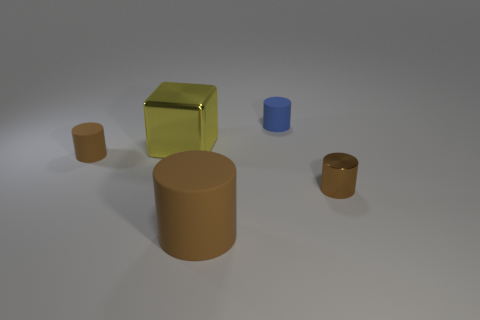What number of large objects are green matte spheres or matte things?
Offer a very short reply. 1. How many yellow things have the same material as the tiny blue cylinder?
Offer a terse response. 0. Do the rubber cylinder behind the yellow shiny block and the object right of the tiny blue object have the same size?
Provide a short and direct response. Yes. What material is the small brown cylinder on the left side of the brown cylinder that is in front of the brown shiny thing made of?
Your answer should be very brief. Rubber. Are there fewer small brown metal things that are on the left side of the big brown cylinder than small rubber cylinders right of the metallic cube?
Make the answer very short. Yes. What material is the other tiny thing that is the same color as the tiny metallic thing?
Offer a very short reply. Rubber. Are there any other things that are the same shape as the tiny blue object?
Offer a very short reply. Yes. There is a tiny brown cylinder that is to the left of the big yellow object; what material is it?
Make the answer very short. Rubber. Are there any yellow shiny things on the right side of the small blue cylinder?
Keep it short and to the point. No. What is the shape of the tiny metal object?
Provide a short and direct response. Cylinder. 